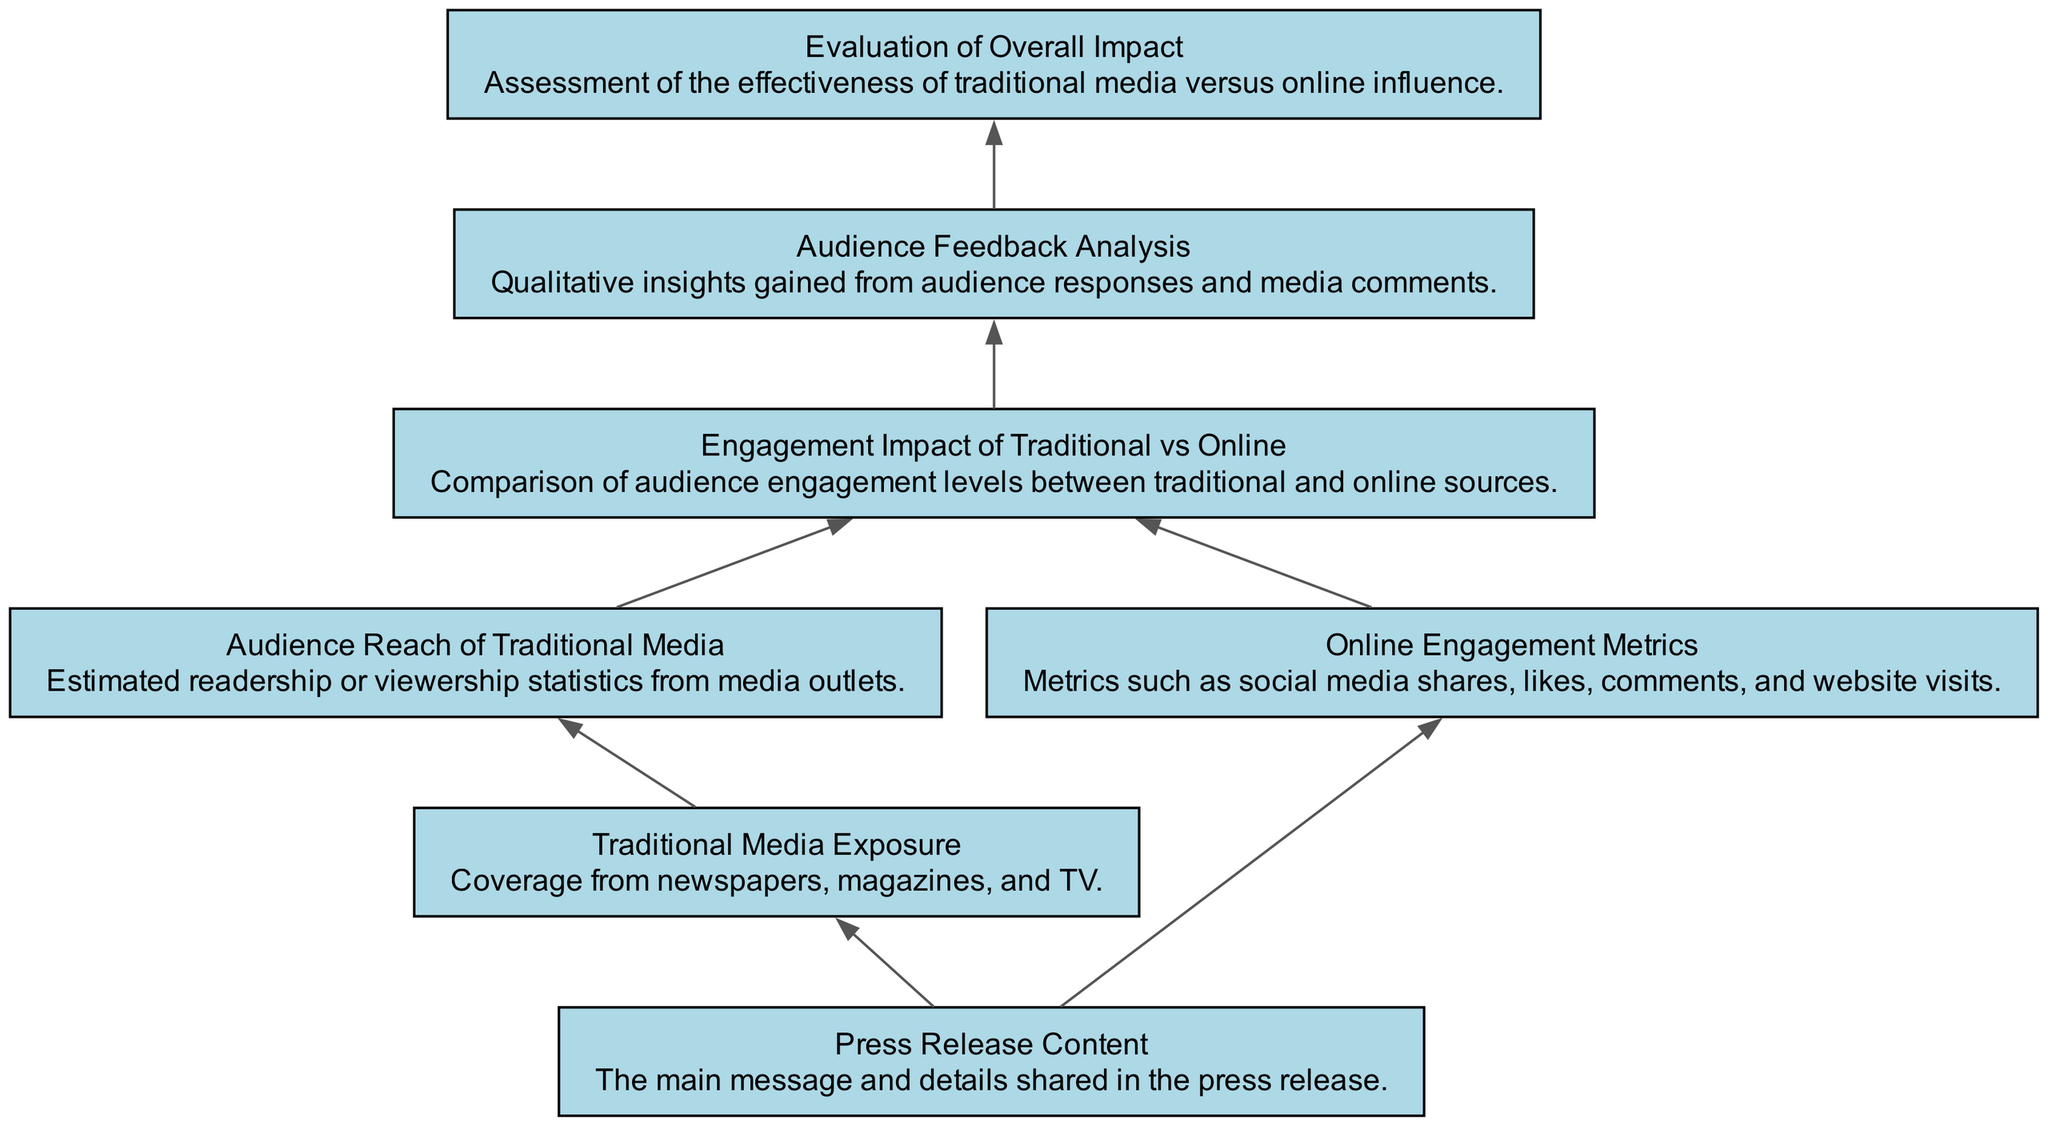What is the first node in the diagram? The first node in the diagram is traditionally defined as the one that does not have any incoming edges. In this diagram, "Press Release Content" is the first node because it is the starting point from which traditional media and online metrics are derived.
Answer: Press Release Content How many nodes are present in the diagram? To find the total number of nodes, we count each unique element defined in the data section. The elements are "Traditional Media Exposure," "Press Release Content," "Audience Reach of Traditional Media," "Online Engagement Metrics," "Engagement Impact of Traditional vs Online," "Audience Feedback Analysis," and "Evaluation of Overall Impact," totaling seven nodes.
Answer: 7 What do the edges represent in this diagram? In this flow chart, edges represent the relationships or dependencies between nodes. They illustrate how various components interact and lead from one aspect of the media exposure analysis to another, showing the flow of information from input to evaluation.
Answer: Relationships between nodes Which node connects "Traditional Media Exposure" to "Media Reach"? The edge directly connects "Traditional Media Exposure" to "Media Reach," indicating that the coverage obtained from traditional media influences the audience reach statistics derived from this coverage.
Answer: Media Reach Which two components directly contribute to "Media Impact"? The two components that directly contribute to "Media Impact" in the diagram are "Audience Reach of Traditional Media" and "Online Engagement Metrics." They both provide metrics that are compared to determine overall media impact.
Answer: Audience Reach of Traditional Media and Online Engagement Metrics Explain the flow from "Online Engagement Metrics" to "Final Evaluation." The flow begins at the "Online Engagement Metrics," which gathers data such as social media shares and website visits. This information feeds into the "Engagement Impact of Traditional vs Online," which assesses the engagement levels of both media types. Finally, this comparative analysis leads to the "Evaluation of Overall Impact," where the effectiveness of both traditional and online media is assessed based on the gathered data.
Answer: Steps from Online Engagement Metrics to Final Evaluation involve gathering metrics, assessing engagement impact, and evaluating overall effectiveness What does the "Audience Feedback Analysis" node represent? This node represents the qualitative insights obtained from the audience's responses and media comments. It serves as a way to interpret how the audience perceives the media coverage, providing context to the engagement metrics collected.
Answer: Qualitative insights from audience responses Which node is the last in the flow? The last node in the flow is "Evaluation of Overall Impact," as it is the final point to which all preceding nodes lead. It summarizes and assesses the results gathered from previous analyses and feedback mechanisms.
Answer: Evaluation of Overall Impact 